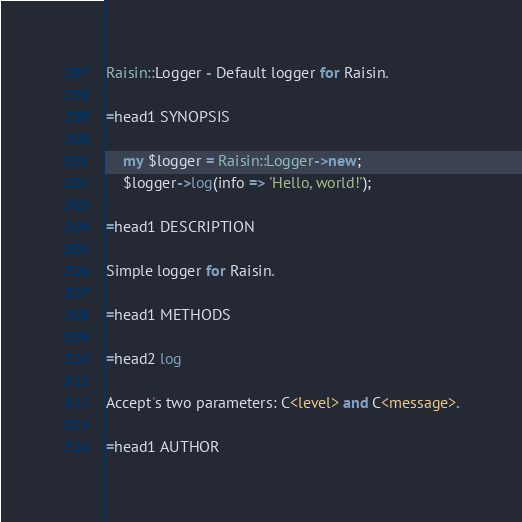<code> <loc_0><loc_0><loc_500><loc_500><_Perl_>
Raisin::Logger - Default logger for Raisin.

=head1 SYNOPSIS

    my $logger = Raisin::Logger->new;
    $logger->log(info => 'Hello, world!');

=head1 DESCRIPTION

Simple logger for Raisin.

=head1 METHODS

=head2 log

Accept's two parameters: C<level> and C<message>.

=head1 AUTHOR
</code> 